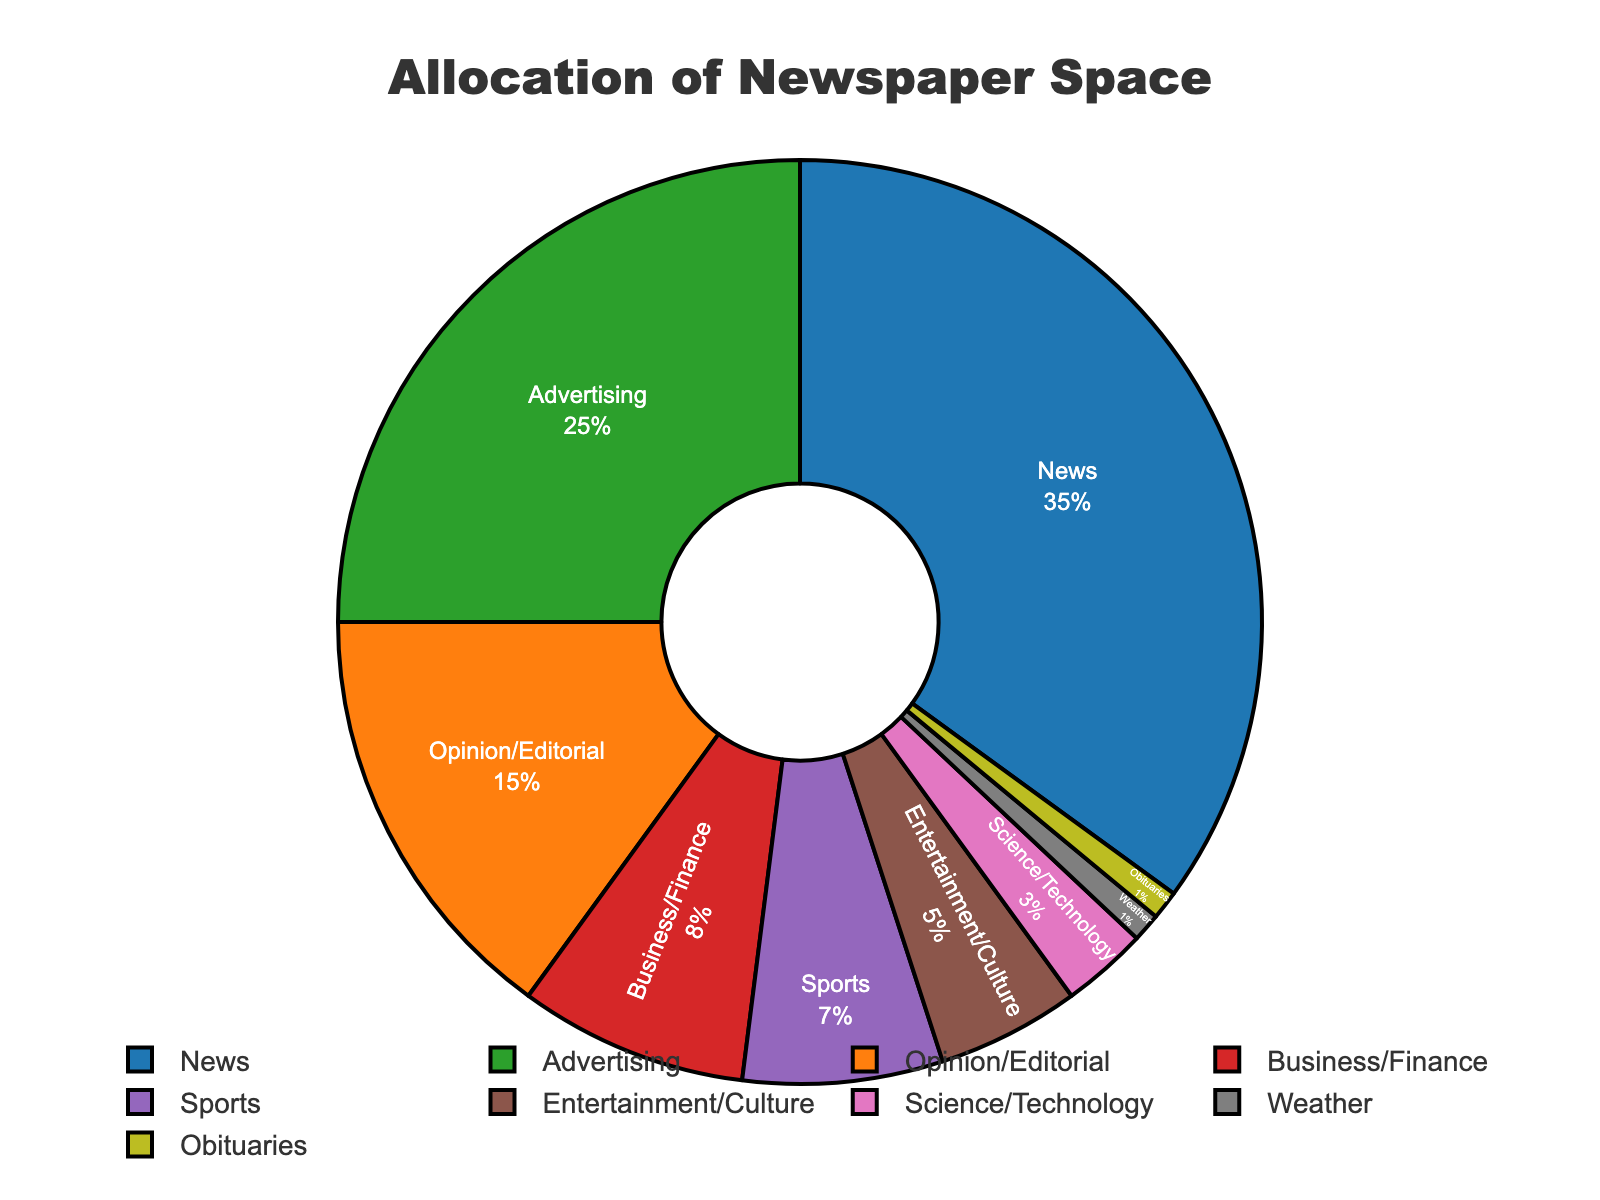What percentage of newspaper space is allocated to Advertising? Look at the pie chart and find the section labeled "Advertising." The percentage value indicated inside this section is the answer.
Answer: 25% What two content types together take up 20% of the newspaper space? Identify sections in the pie chart and find two that total 20%. "Science/Technology" (3%) and "Sports" (7%) together with "Weather" (1%) and "Obituaries" (1%) add up to 20%.
Answer: Sports (7%) + Entertainment/Culture (5%) + Science/Technology (3%) + Weather (1%) + Obituaries (1%) Which content type occupies a larger percentage of newspaper space: Business/Finance or Sports? Compare the size of the sections labeled "Business/Finance" and "Sports" in the pie chart. "Business/Finance" is 8% and "Sports" is 7%.
Answer: Business/Finance What is the difference in the percentage of newspaper space allocated to News and Opinion/Editorial? Subtract the percentage of "Opinion/Editorial" from "News." "News" is 35% and "Opinion/Editorial" is 15%.
Answer: 20% How much more space is allocated to Entertainment/Culture than to Science/Technology? Find the percentage for "Entertainment/Culture" and "Science/Technology," then subtract the latter from the former. "Entertainment/Culture" is 5% and "Science/Technology" is 3%.
Answer: 2% Which content type gets the smallest allocation of newspaper space, and what is its percentage? Identify the smallest piece of the pie chart. Both "Weather" and "Obituaries" are the smallest, each occupying 1%.
Answer: Weather and Obituaries, 1% What is the total percentage of newspaper space dedicated to content types other than News and Advertising? Sum the percentages of all sections not labeled "News" or "Advertising." 15% (Opinion/Editorial) + 8% (Business/Finance) + 7% (Sports) + 5% (Entertainment/Culture) + 3% (Science/Technology) + 1% (Weather) + 1% (Obituaries) = 40%
Answer: 40% Which colors represent the sections News and Advertising? Identify the colors of the sections labeled "News" and "Advertising" in the pie chart. "News" is represented by blue, and "Advertising" by orange.
Answer: Blue for News, Orange for Advertising Between Opinion/Editorial and Business/Finance, which gets more space and by how much? Compare the percentages of "Opinion/Editorial" and "Business/Finance" and subtract the smaller from the larger. "Opinion/Editorial" is 15% and "Business/Finance" is 8%.
Answer: Opinion/Editorial by 7% 